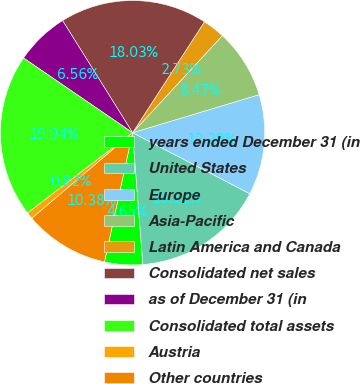Convert chart. <chart><loc_0><loc_0><loc_500><loc_500><pie_chart><fcel>years ended December 31 (in<fcel>United States<fcel>Europe<fcel>Asia-Pacific<fcel>Latin America and Canada<fcel>Consolidated net sales<fcel>as of December 31 (in<fcel>Consolidated total assets<fcel>Austria<fcel>Other countries<nl><fcel>4.65%<fcel>16.12%<fcel>12.29%<fcel>8.47%<fcel>2.73%<fcel>18.03%<fcel>6.56%<fcel>19.94%<fcel>0.82%<fcel>10.38%<nl></chart> 